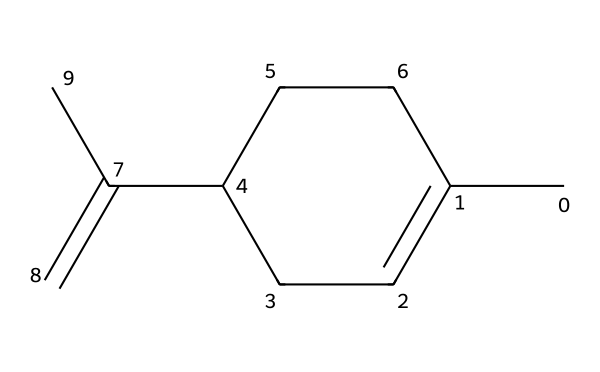What is the molecular formula of limonene? Counting the atoms in the SMILES representation, there are 10 carbon atoms and 16 hydrogen atoms. This gives the molecular formula of limonene as C10H16.
Answer: C10H16 How many double bonds are present in limonene? The structure shows two double bonds in the carbon chain of limonene, which can be seen from the ‘=’ signs in the SMILES representation.
Answer: 2 Is limonene an aromatic compound? The cyclic structure is evident, but limonene does not possess a benzene ring or any delocalized pi electrons that define aromaticity, thus it is not classified as aromatic.
Answer: No What characteristic odor is limonene associated with? Given that limonene is derived from citrus fruits, it is commonly associated with a strong citrus scent, such as that of oranges or lemons.
Answer: Citrus Which functional group is prominent in limonene? Even though limonene is primarily a hydrocarbon, it contains a double bond that classifies it as an alkene. This is indicated by the presence of multiple connected carbons with double bonds.
Answer: Alkene How many rings are there in the structure of limonene? Analyzing the SMILES shows that there is one ring structure present (indicated by "C1" which denotes the start of a cyclic structure), confirming it contains a cycloalkane portion.
Answer: 1 Does limonene have a pleasant or unpleasant scent? Known for its sweet and refreshing aroma, limonene is widely regarded as having a pleasant scent, making it popular in fragrances and household products.
Answer: Pleasant 